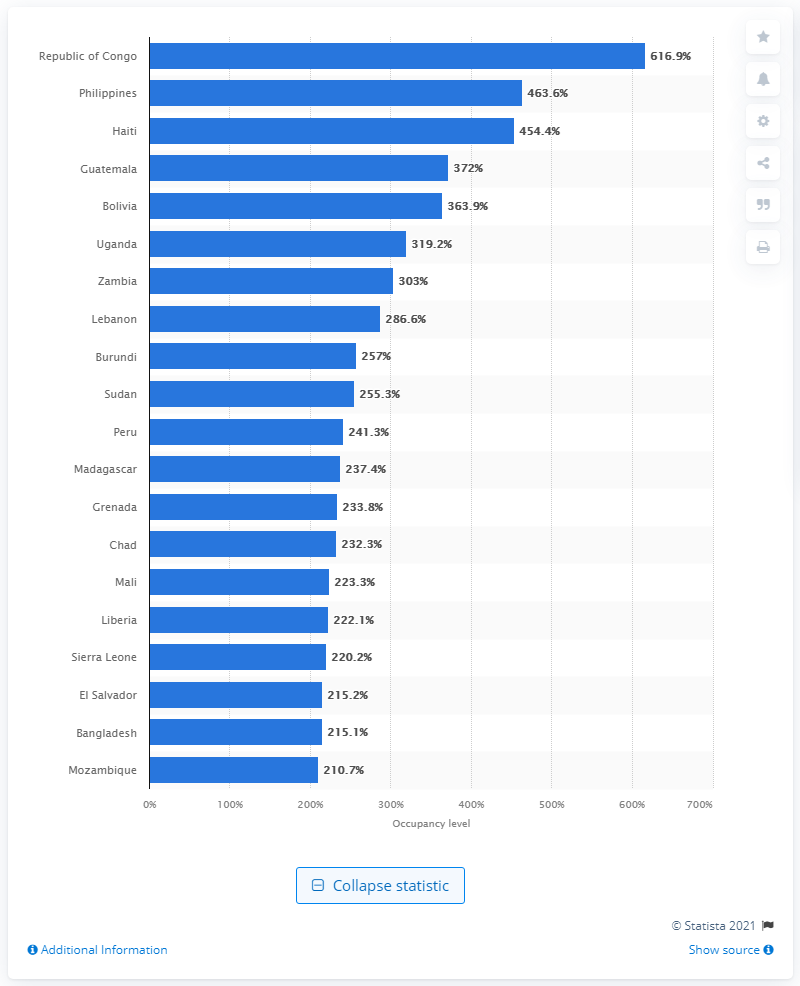Give some essential details in this illustration. The Philippines had the second highest prison occupancy in the country. In June 2020, the prison occupancy rate in the Congo was 616.9 prisoners per 100,000 inhabitants. According to data as of June 2020, the Republic of Congo had the highest prison occupancy among all countries. In June 2020, the prison occupancy rate in the Philippines was 463.6%. 